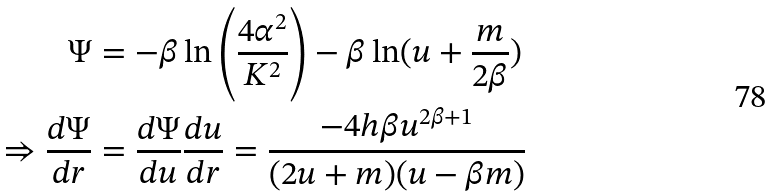Convert formula to latex. <formula><loc_0><loc_0><loc_500><loc_500>\Psi & = - \beta \ln \left ( \frac { 4 \alpha ^ { 2 } } { K ^ { 2 } } \right ) - \beta \ln ( u + \frac { m } { 2 \beta } ) \\ \Rightarrow \frac { d \Psi } { d r } & = \frac { d \Psi } { d u } \frac { d u } { d r } = \frac { - 4 h \beta u ^ { 2 \beta + 1 } } { ( 2 u + m ) ( u - \beta m ) }</formula> 